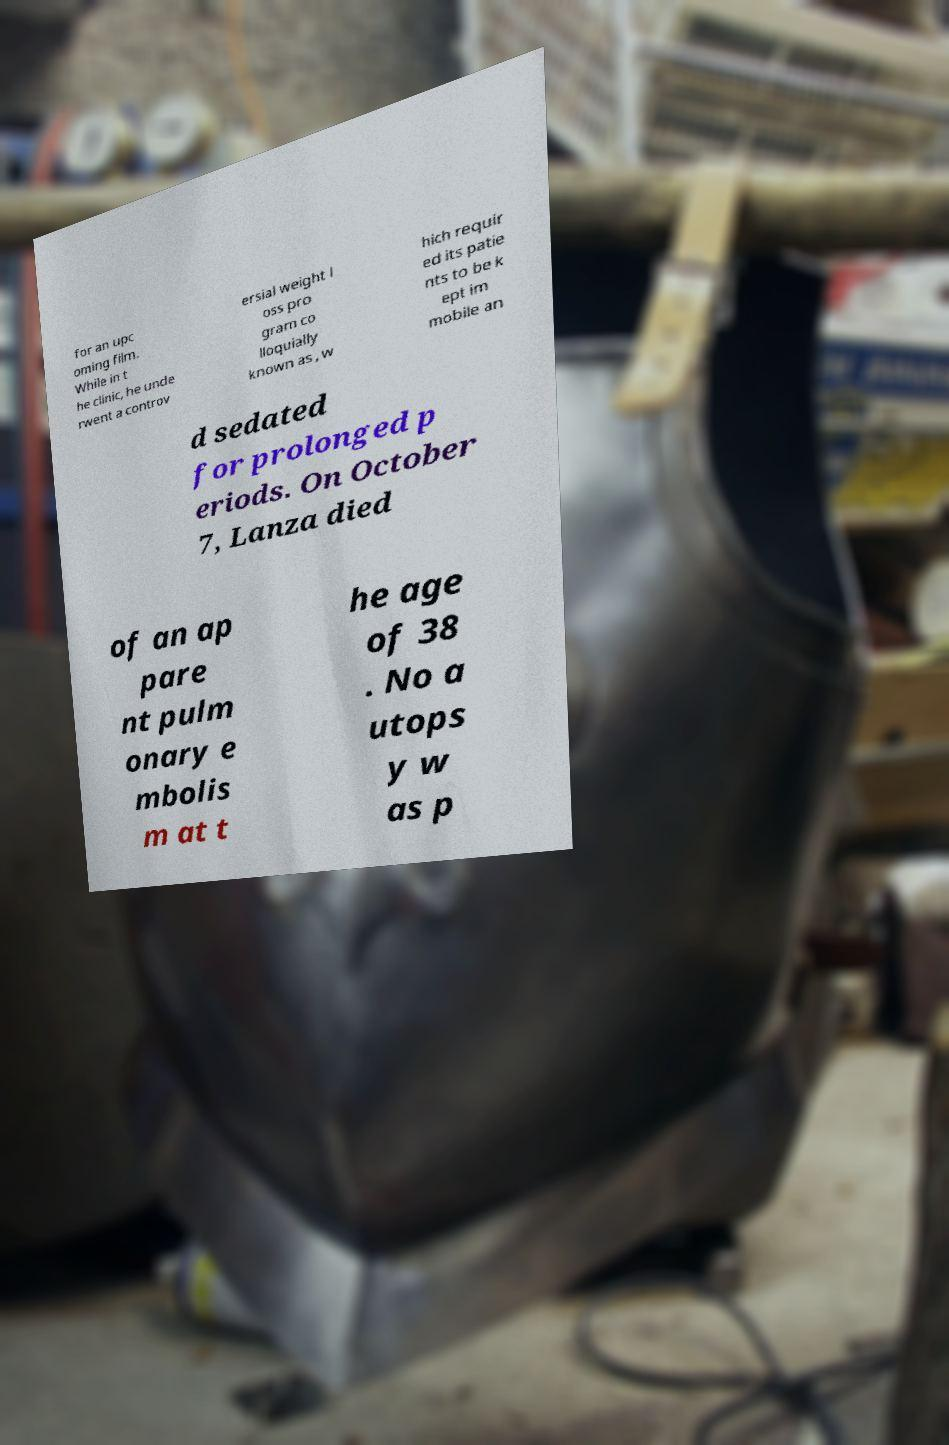Could you extract and type out the text from this image? for an upc oming film. While in t he clinic, he unde rwent a controv ersial weight l oss pro gram co lloquially known as , w hich requir ed its patie nts to be k ept im mobile an d sedated for prolonged p eriods. On October 7, Lanza died of an ap pare nt pulm onary e mbolis m at t he age of 38 . No a utops y w as p 